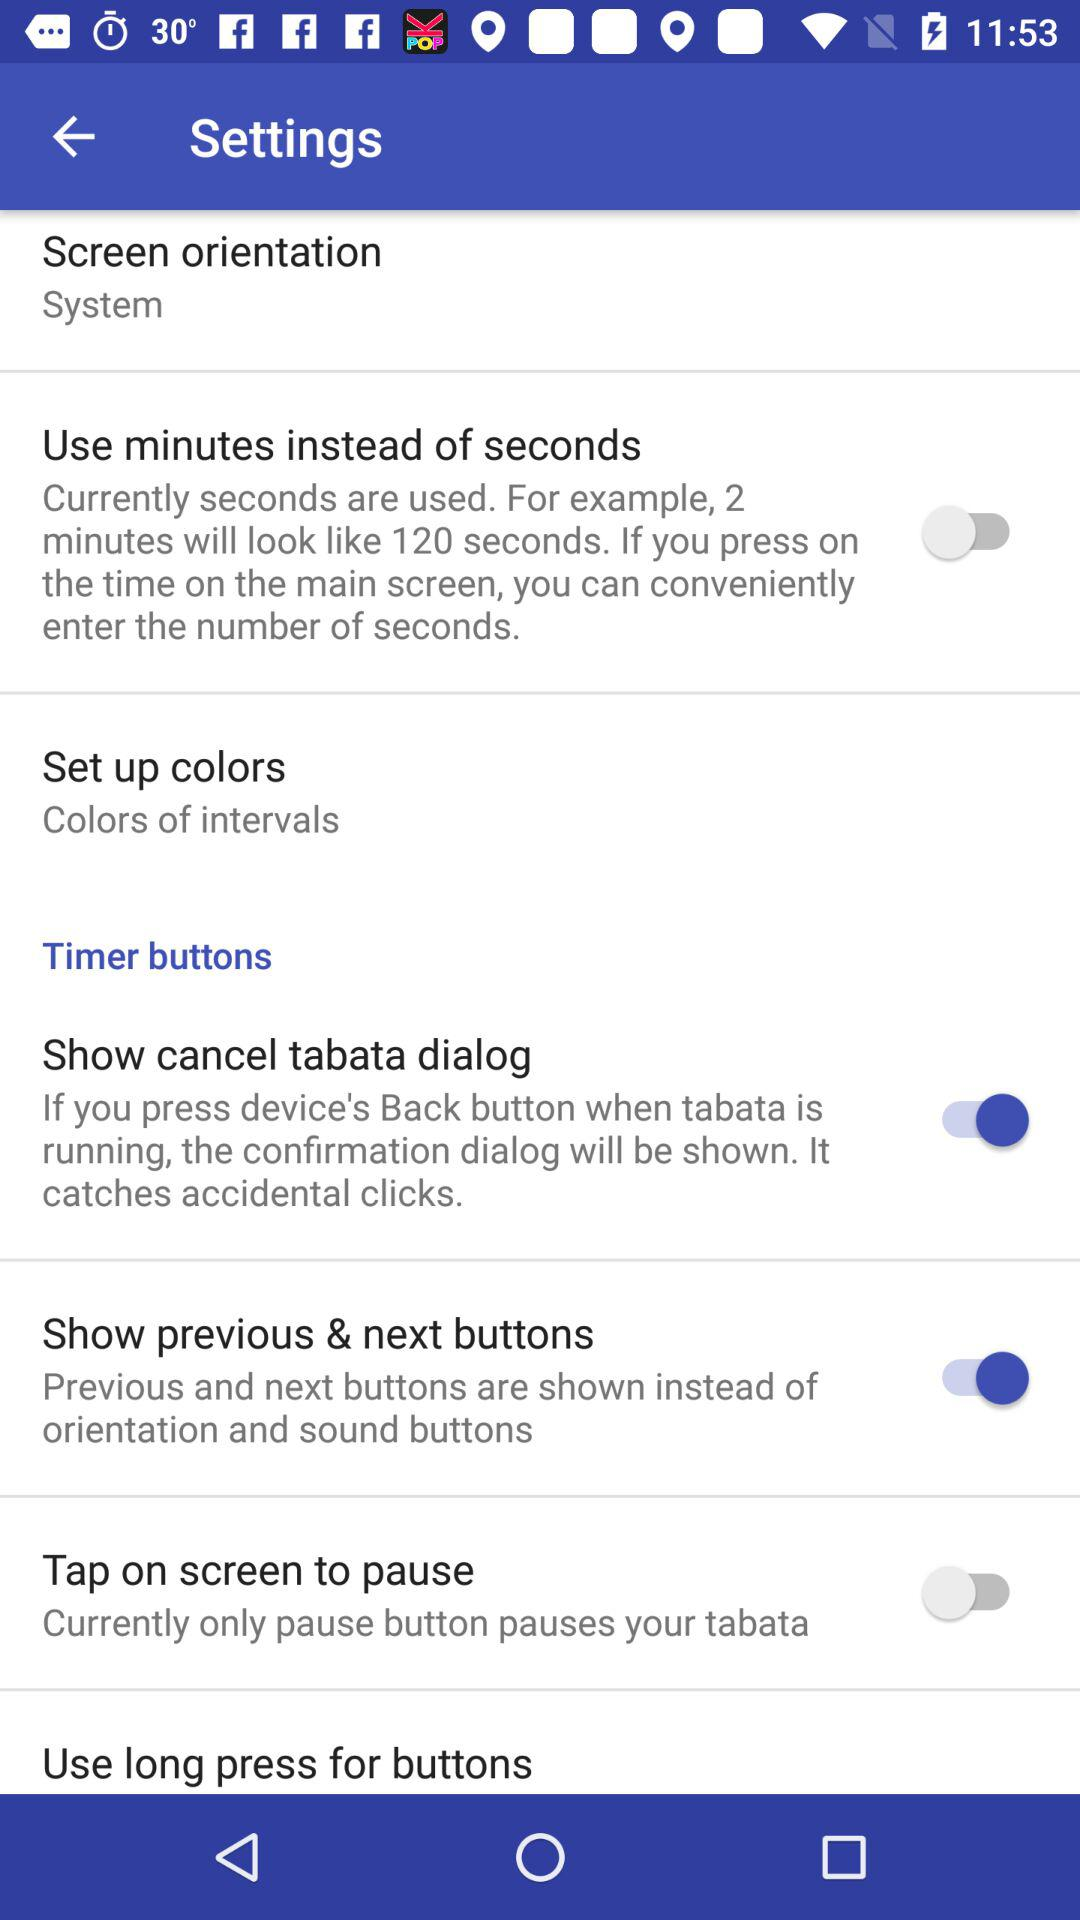What is the screen orientation? The screen orientation is "System". 